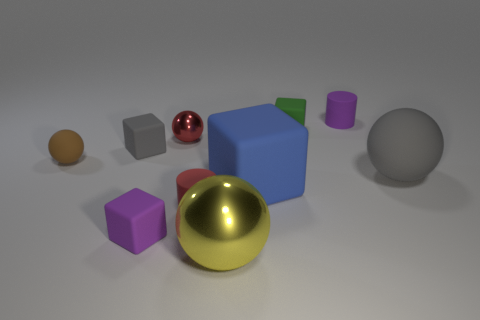Can you identify the shapes of the objects in the image? Certainly, the image features a variety of geometric shapes including spheres, cubes, and cylinders. Do the objects appear to be arranged in a particular pattern or randomly? The objects seem to be arranged randomly on the surface without any discernible pattern, spread out to display their various shapes and colors. 